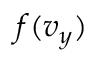Convert formula to latex. <formula><loc_0><loc_0><loc_500><loc_500>f ( v _ { y } )</formula> 